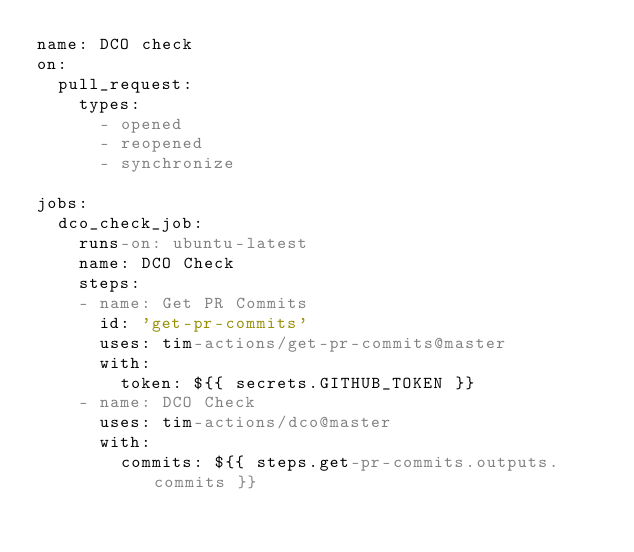<code> <loc_0><loc_0><loc_500><loc_500><_YAML_>name: DCO check
on: 
  pull_request:
    types:
      - opened
      - reopened
      - synchronize

jobs:
  dco_check_job:
    runs-on: ubuntu-latest
    name: DCO Check
    steps:
    - name: Get PR Commits
      id: 'get-pr-commits'
      uses: tim-actions/get-pr-commits@master
      with:
        token: ${{ secrets.GITHUB_TOKEN }}
    - name: DCO Check
      uses: tim-actions/dco@master
      with:
        commits: ${{ steps.get-pr-commits.outputs.commits }}</code> 